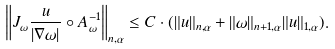<formula> <loc_0><loc_0><loc_500><loc_500>\left \| J _ { \omega } \frac { u } { | \nabla \omega | } \circ A _ { \omega } ^ { - 1 } \right \| _ { n , \alpha } \leq C \cdot ( \| u \| _ { n , \alpha } + \| \omega \| _ { n + 1 , \alpha } \| u \| _ { 1 , \alpha } ) .</formula> 